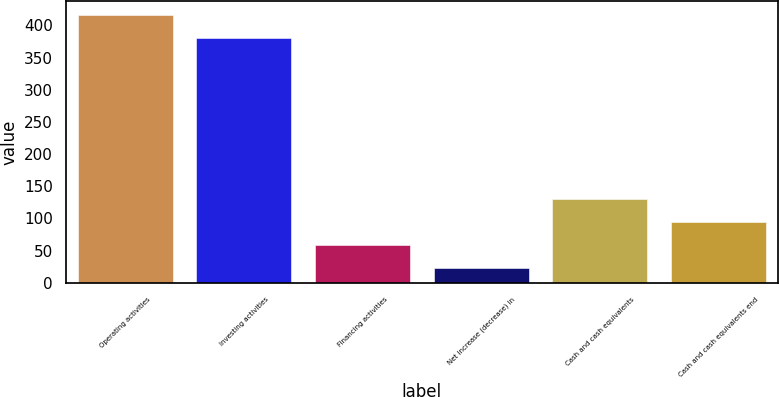<chart> <loc_0><loc_0><loc_500><loc_500><bar_chart><fcel>Operating activities<fcel>Investing activities<fcel>Financing activities<fcel>Net increase (decrease) in<fcel>Cash and cash equivalents<fcel>Cash and cash equivalents end<nl><fcel>416.3<fcel>380.5<fcel>59.3<fcel>23.5<fcel>130.9<fcel>95.1<nl></chart> 